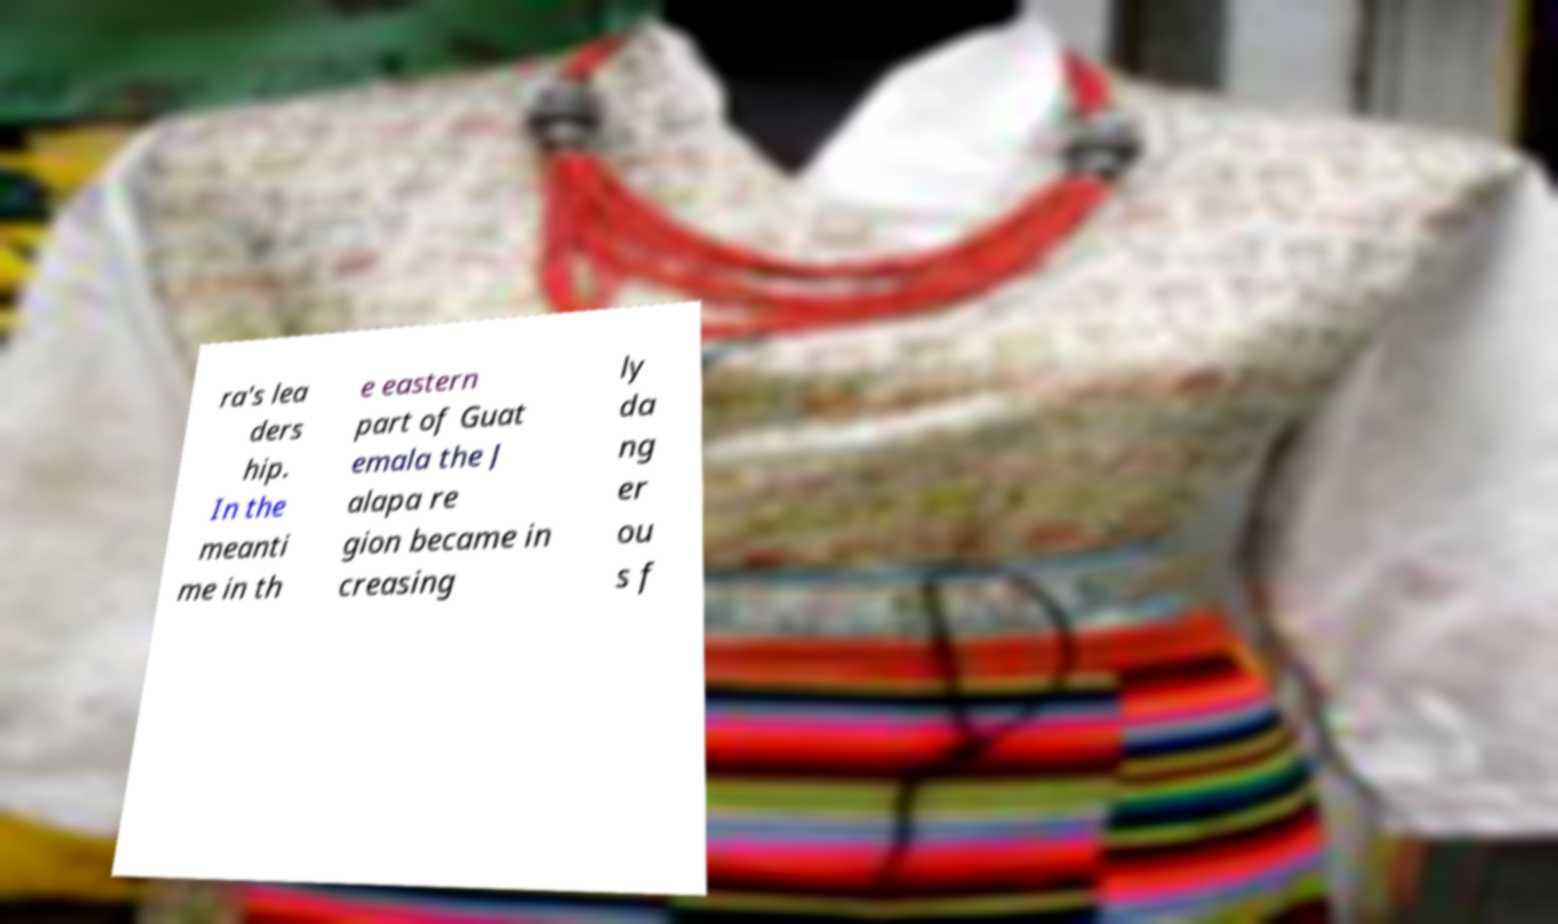Can you read and provide the text displayed in the image?This photo seems to have some interesting text. Can you extract and type it out for me? ra's lea ders hip. In the meanti me in th e eastern part of Guat emala the J alapa re gion became in creasing ly da ng er ou s f 